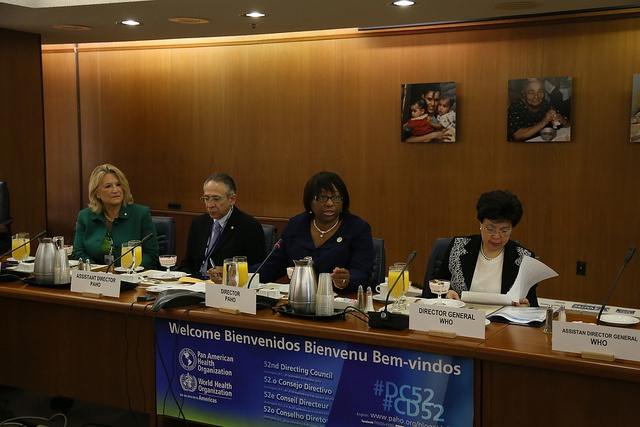Describe the objects in this image and their specific colors. I can see people in darkgray, black, maroon, and gray tones, people in darkgray, black, tan, maroon, and gray tones, people in darkgray, black, maroon, and darkgreen tones, people in darkgray, black, maroon, and gray tones, and people in darkgray, black, maroon, and gray tones in this image. 